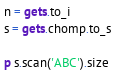<code> <loc_0><loc_0><loc_500><loc_500><_Ruby_>n = gets.to_i
s = gets.chomp.to_s

p s.scan('ABC').size
</code> 